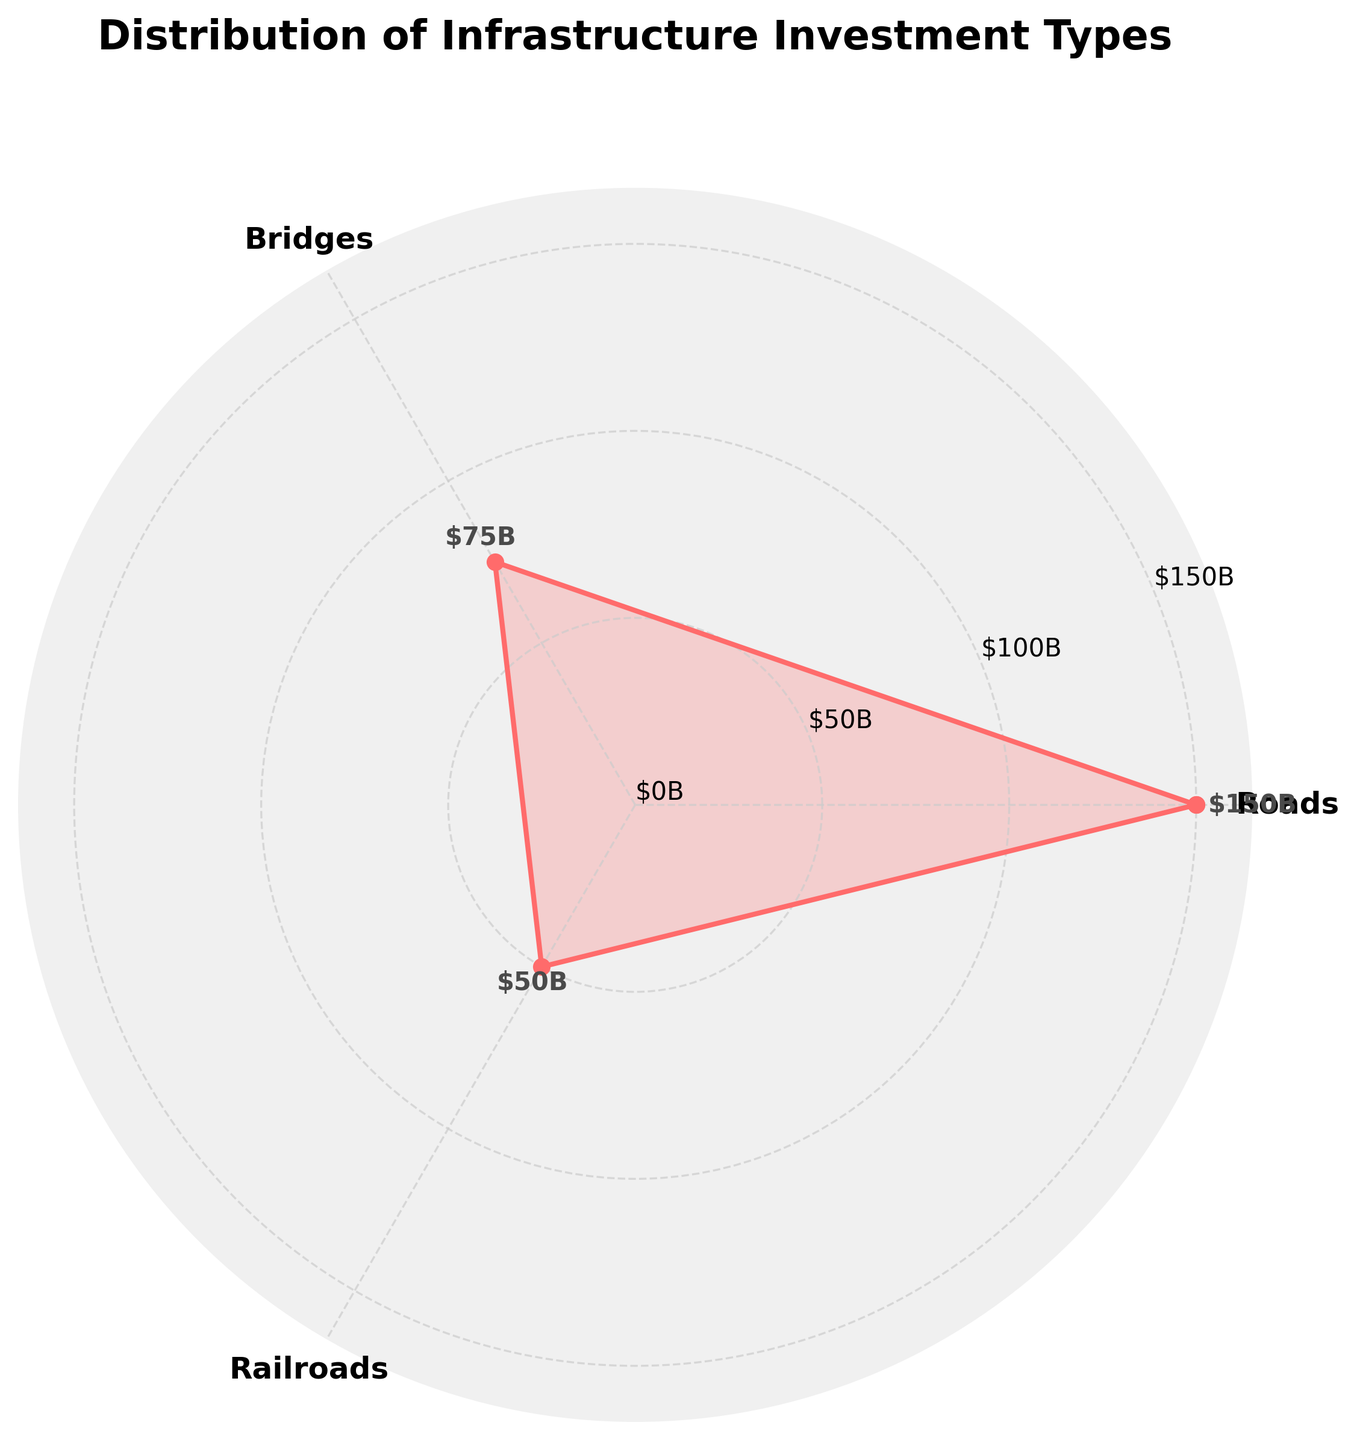Which infrastructure investment type has the highest amount? The figure shows three categories: Roads, Bridges, and Railroads. The investment amount for each type is marked on the plot and Roads have the highest amount.
Answer: Roads What is the total investment amount in all infrastructure types? The total investment amount can be determined by adding up the investments in Roads ($150B), Bridges ($75B), and Railroads ($50B). This sums up to $150B + $75B + $50B = $275B.
Answer: $275B How much more investment is allocated to Roads compared to Railroads? To determine the additional investment in Roads compared to Railroads, subtract the investment in Railroads ($50B) from the investment in Roads ($150B). The difference is $150B - $50B = $100B.
Answer: $100B Which two infrastructure types have the closest investment amounts? By comparing the amounts on the chart, Bridges ($75B) and Railroads ($50B) are the closest in investment values. The difference between them is $75B - $50B = $25B, smaller than other pair differences.
Answer: Bridges and Railroads What percentage of the total investment does Railroads represent? To find the percentage, divide the investment in Railroads ($50B) by the total investment ($275B) and then multiply by 100. The calculation is (50 / 275) * 100 ≈ 18.18%.
Answer: 18.18% If investment in Bridges increased by $25B, how would it compare to the investment in Roads? Currently, Bridges have $75B. If increased by $25B, it becomes $75B + $25B = $100B. Comparing to Roads' $150B, Bridges would still have $50B less than Roads.
Answer: $50B less What is the ratio of the investment in Roads to the investment in Bridges? The ratio of Roads investment ($150B) to Bridges investment ($75B) is calculated by dividing $150B by $75B. The ratio is 150 / 75 = 2.
Answer: 2 By how much does the investment in Roads exceed the combined investment in Bridges and Railroads? The combined investment in Bridges ($75B) and Railroads ($50B) is $75B + $50B = $125B. The excess investment in Roads is $150B - $125B = $25B.
Answer: $25B Does any infrastructure type have less than half the investment of Bridges? Railroads have $50B while Bridges have $75B. Half of Bridges' investment is $75B / 2 = $37.5B, and Railroads ($50B) have more than this amount. No type has less than half.
Answer: No What is the average investment amount across all types of infrastructure? The total investment amount is $275B across three types. The average investment amount is found by dividing $275B by 3, which is 275 / 3 ≈ $91.67B.
Answer: $91.67B 